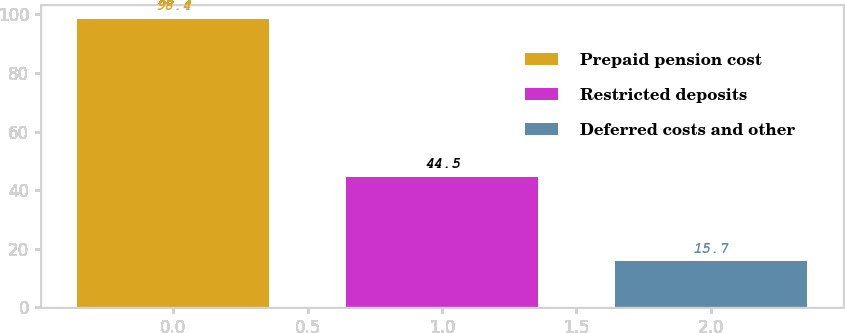Convert chart to OTSL. <chart><loc_0><loc_0><loc_500><loc_500><bar_chart><fcel>Prepaid pension cost<fcel>Restricted deposits<fcel>Deferred costs and other<nl><fcel>98.4<fcel>44.5<fcel>15.7<nl></chart> 